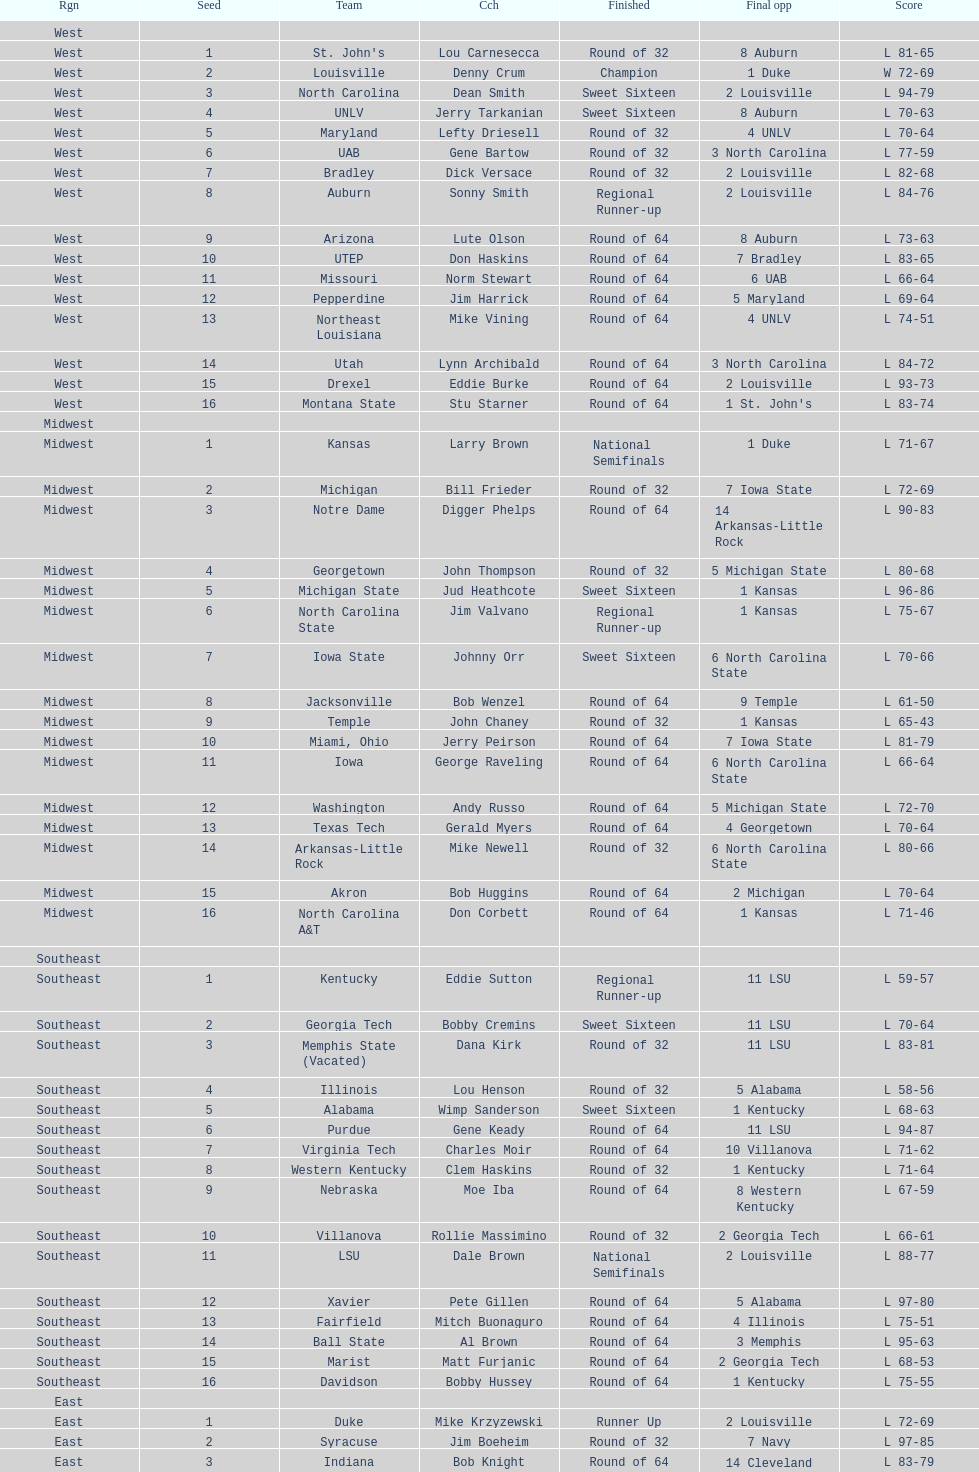North carolina and unlv each made it to which round? Sweet Sixteen. 